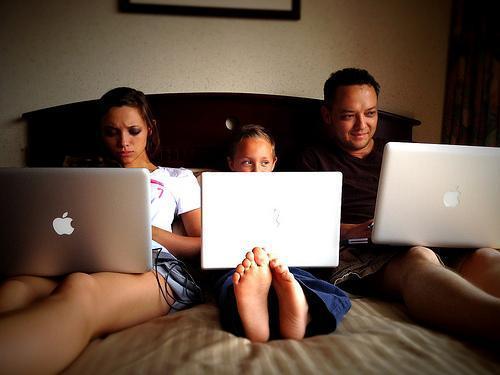How many people are in this scene?
Give a very brief answer. 3. How many people are reading book?
Give a very brief answer. 0. 